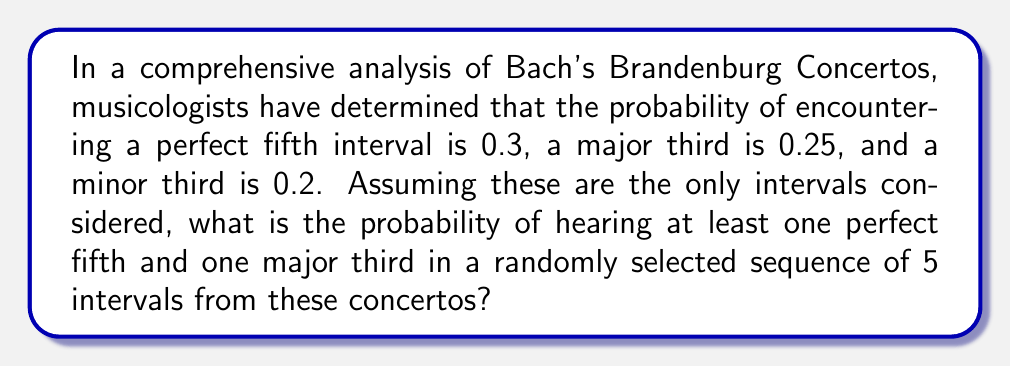Could you help me with this problem? Let's approach this step-by-step:

1) First, we need to calculate the probability of not hearing a perfect fifth in a single interval:
   $P(\text{not perfect fifth}) = 1 - 0.3 = 0.7$

2) Similarly, for not hearing a major third:
   $P(\text{not major third}) = 1 - 0.25 = 0.75$

3) Now, the probability of not hearing at least one perfect fifth in 5 intervals is:
   $P(\text{no perfect fifth in 5}) = 0.7^5 = 0.16807$

4) And for not hearing at least one major third in 5 intervals:
   $P(\text{no major third in 5}) = 0.75^5 = 0.23730$

5) The probability of hearing at least one perfect fifth AND at least one major third is the complement of the probability of either not hearing a perfect fifth OR not hearing a major third:

   $P(\text{at least one of each}) = 1 - P(\text{no perfect fifth OR no major third})$

6) Using the addition rule of probability:
   $P(\text{no perfect fifth OR no major third}) = P(\text{no perfect fifth}) + P(\text{no major third}) - P(\text{no perfect fifth AND no major third})$

7) $P(\text{no perfect fifth AND no major third}) = 0.16807 \times 0.23730 = 0.03988$

8) Therefore:
   $P(\text{no perfect fifth OR no major third}) = 0.16807 + 0.23730 - 0.03988 = 0.36549$

9) Finally:
   $P(\text{at least one of each}) = 1 - 0.36549 = 0.63451$
Answer: 0.63451 